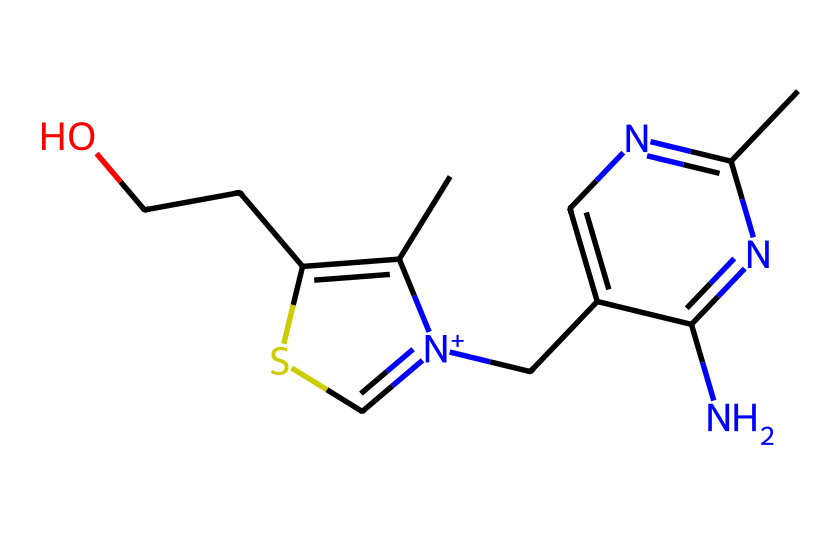What is the primary functional group in thiamine? The functional group identified in thiamine is a thiazole ring containing sulfur, which is significant in organosulfur compounds.
Answer: thiazole How many nitrogen atoms are present in the chemical structure of thiamine? By analyzing the SMILES representation, there are two nitrogen atoms, which can be seen connected in the structure.
Answer: two What is the relationship between thiamine and energy metabolism in athletes? Thiamine is a coenzyme in the metabolism of carbohydrates, crucial for energy production in athletes.
Answer: coenzyme Which organosulfur element is in thiamine? The structure contains sulfur, which is characteristic of organosulfur compounds.
Answer: sulfur How many rings are present in the structure of thiamine? There are two rings: a thiazole ring and a pyrimidine ring, which are part of the overall structure of thiamine.
Answer: two What type of bonds are predominantly found in thiamine's chemical structure? The structure contains both carbon-nitrogen and carbon-sulfur bonds, typical in organosulfur compounds.
Answer: carbon-nitrogen and carbon-sulfur 